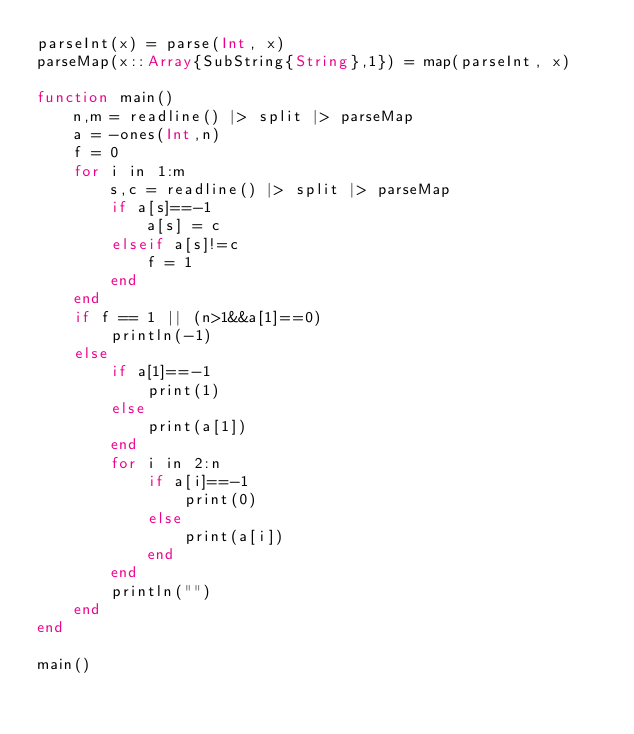<code> <loc_0><loc_0><loc_500><loc_500><_Julia_>parseInt(x) = parse(Int, x)
parseMap(x::Array{SubString{String},1}) = map(parseInt, x)

function main()
	n,m = readline() |> split |> parseMap
	a = -ones(Int,n)
	f = 0
	for i in 1:m
		s,c = readline() |> split |> parseMap
		if a[s]==-1
			a[s] = c
		elseif a[s]!=c
			f = 1
		end
	end
	if f == 1 || (n>1&&a[1]==0)
		println(-1)
	else
		if a[1]==-1
			print(1)
		else
			print(a[1])
		end
		for i in 2:n
			if a[i]==-1
				print(0)
			else
				print(a[i])
			end
		end
		println("")
	end
end

main()</code> 